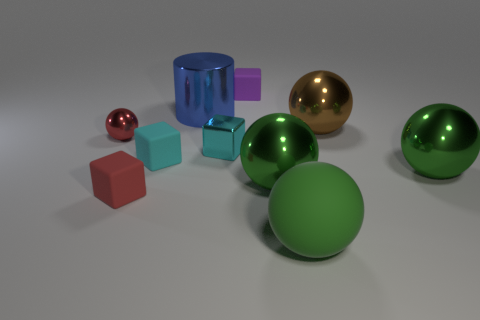How many other objects are there of the same color as the large rubber object?
Offer a terse response. 2. What color is the tiny object that is the same shape as the big brown thing?
Provide a short and direct response. Red. Does the small matte cube to the left of the small cyan matte cube have the same color as the large cylinder?
Keep it short and to the point. No. How many objects are either cubes behind the metal cylinder or cylinders?
Give a very brief answer. 2. What is the material of the green object that is to the right of the ball that is in front of the big green shiny ball that is to the left of the large brown metal thing?
Give a very brief answer. Metal. Are there more green rubber objects that are in front of the big brown metallic sphere than tiny shiny objects that are on the right side of the purple rubber cube?
Offer a very short reply. Yes. How many cubes are either green matte objects or red shiny objects?
Ensure brevity in your answer.  0. What number of cyan cubes are to the left of the metal sphere to the left of the tiny rubber object behind the large blue shiny cylinder?
Keep it short and to the point. 0. There is a thing that is the same color as the tiny shiny ball; what material is it?
Offer a very short reply. Rubber. Are there more gray metallic things than big green things?
Your answer should be very brief. No. 